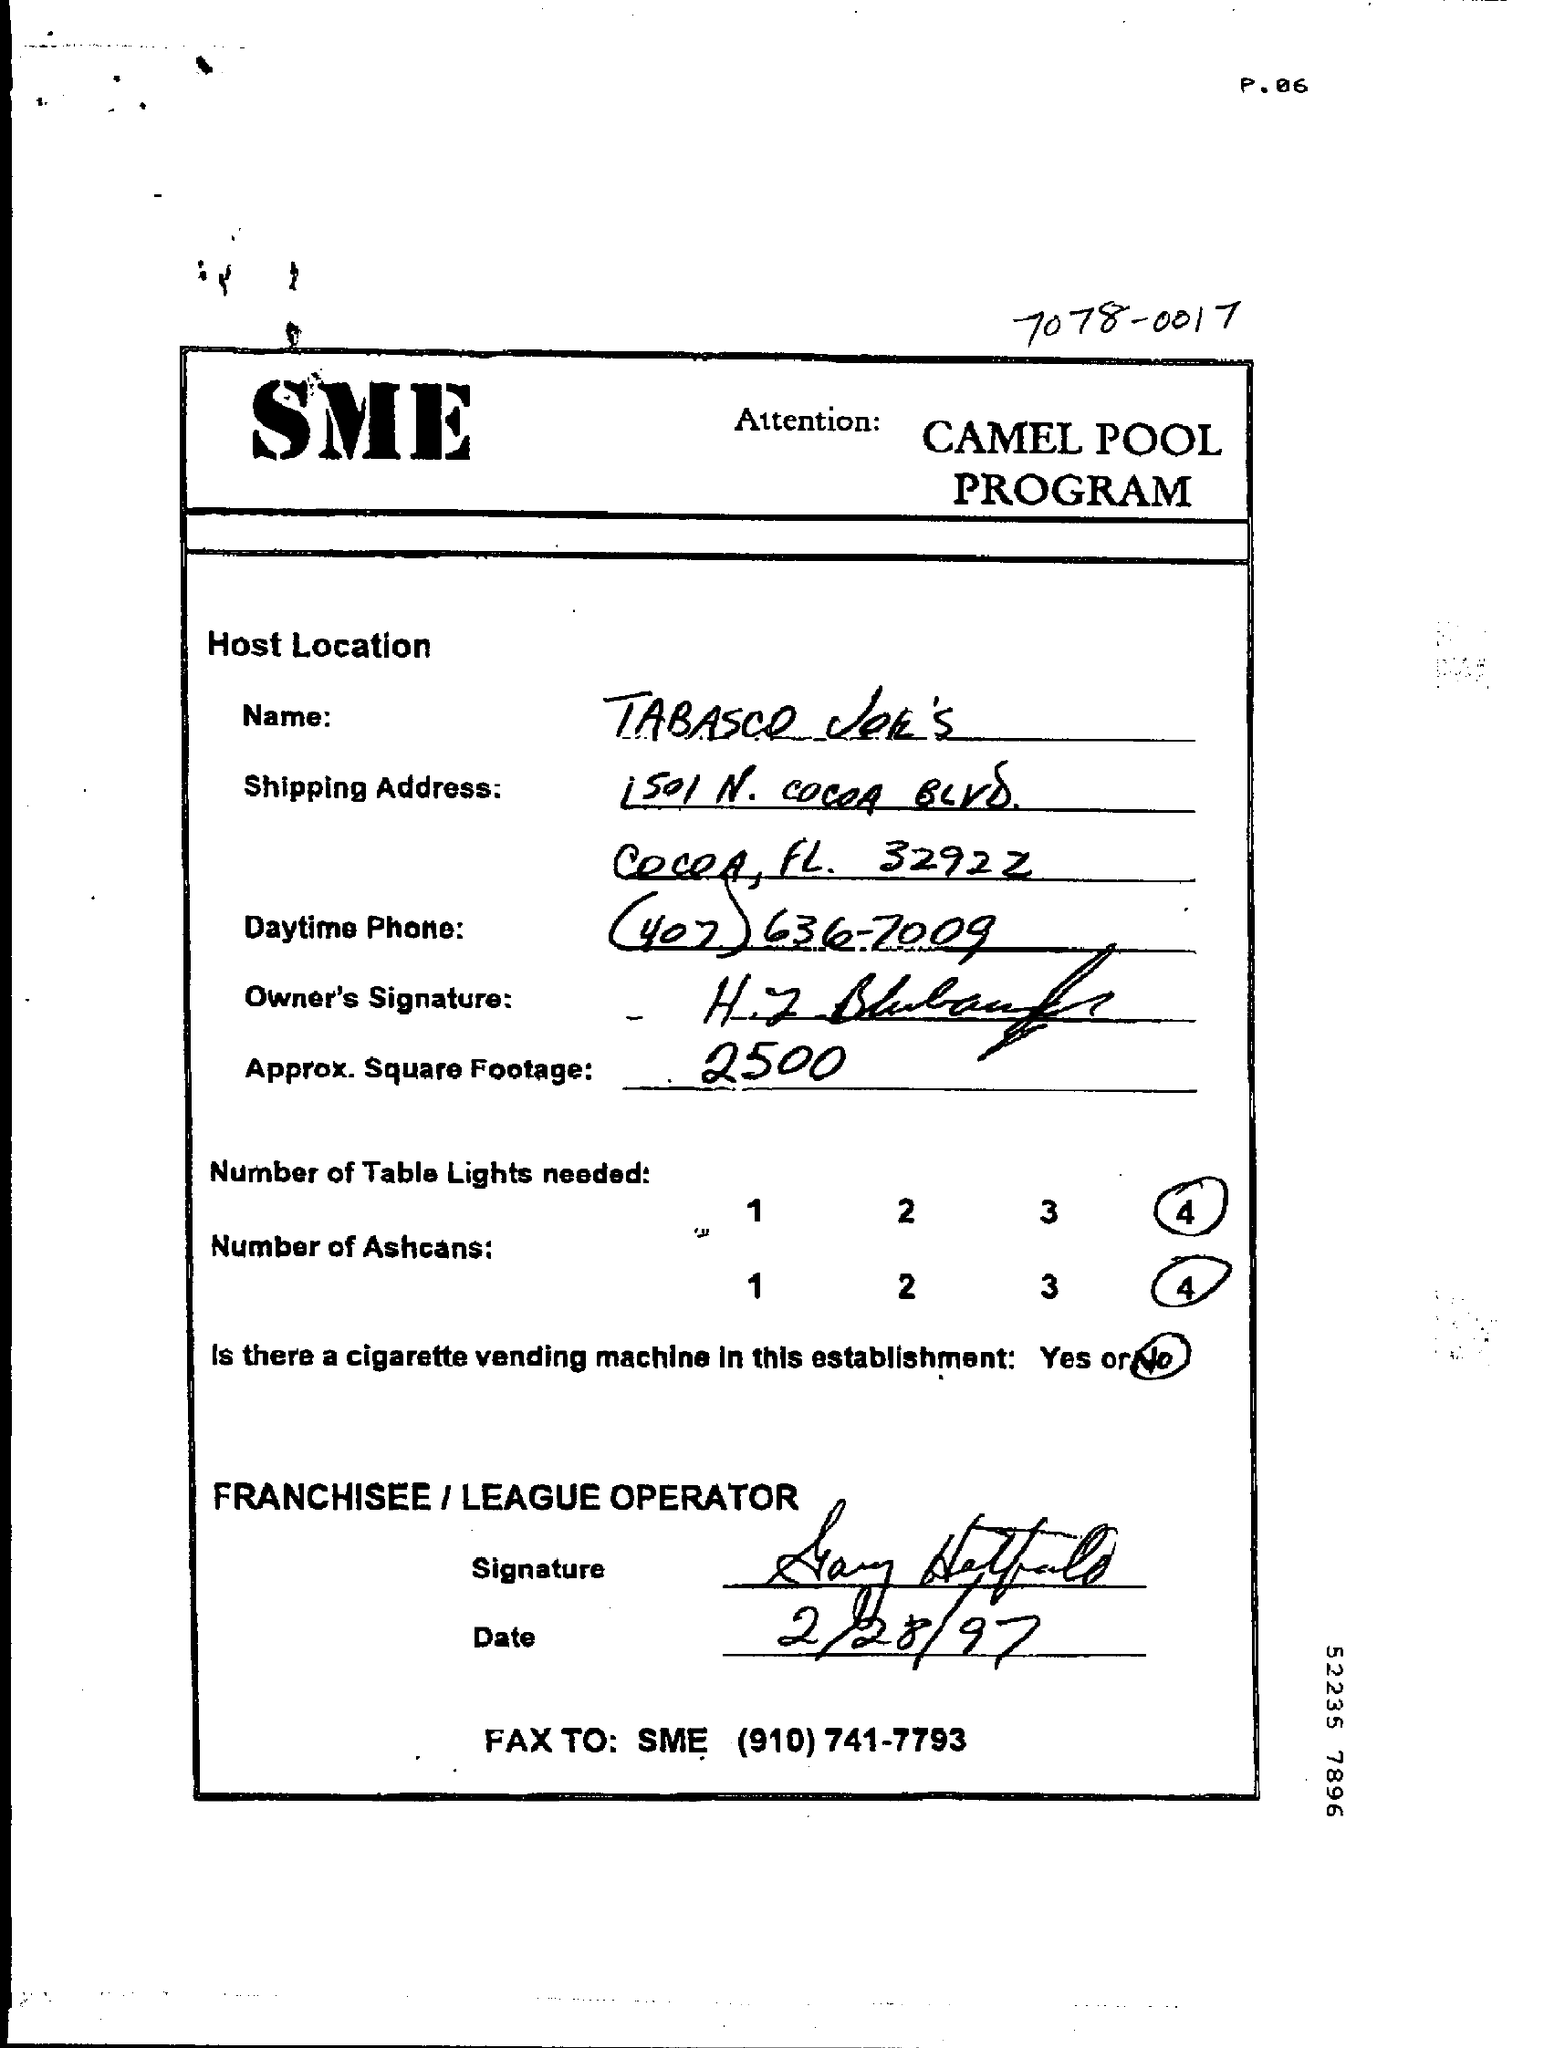What is the approx square footage?
Provide a short and direct response. 2500. 